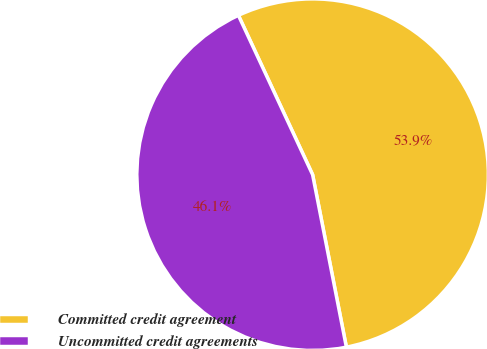Convert chart. <chart><loc_0><loc_0><loc_500><loc_500><pie_chart><fcel>Committed credit agreement<fcel>Uncommitted credit agreements<nl><fcel>53.86%<fcel>46.14%<nl></chart> 